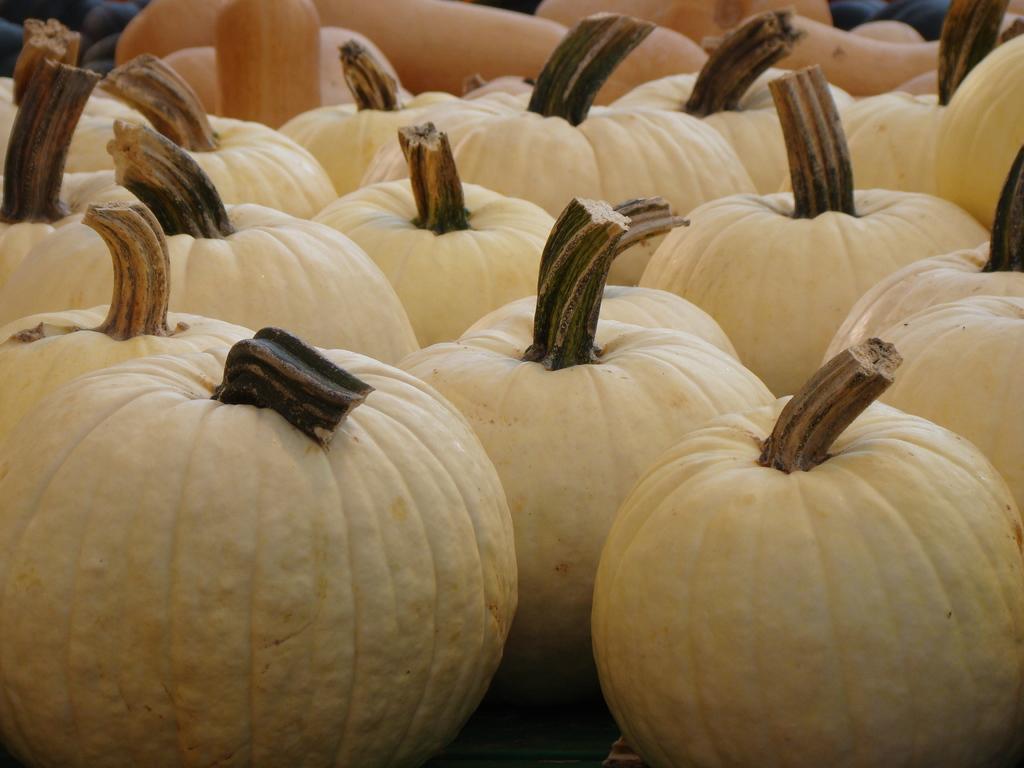In one or two sentences, can you explain what this image depicts? In this image we can see some pumpkins and at the top of the image we can see some objects. 